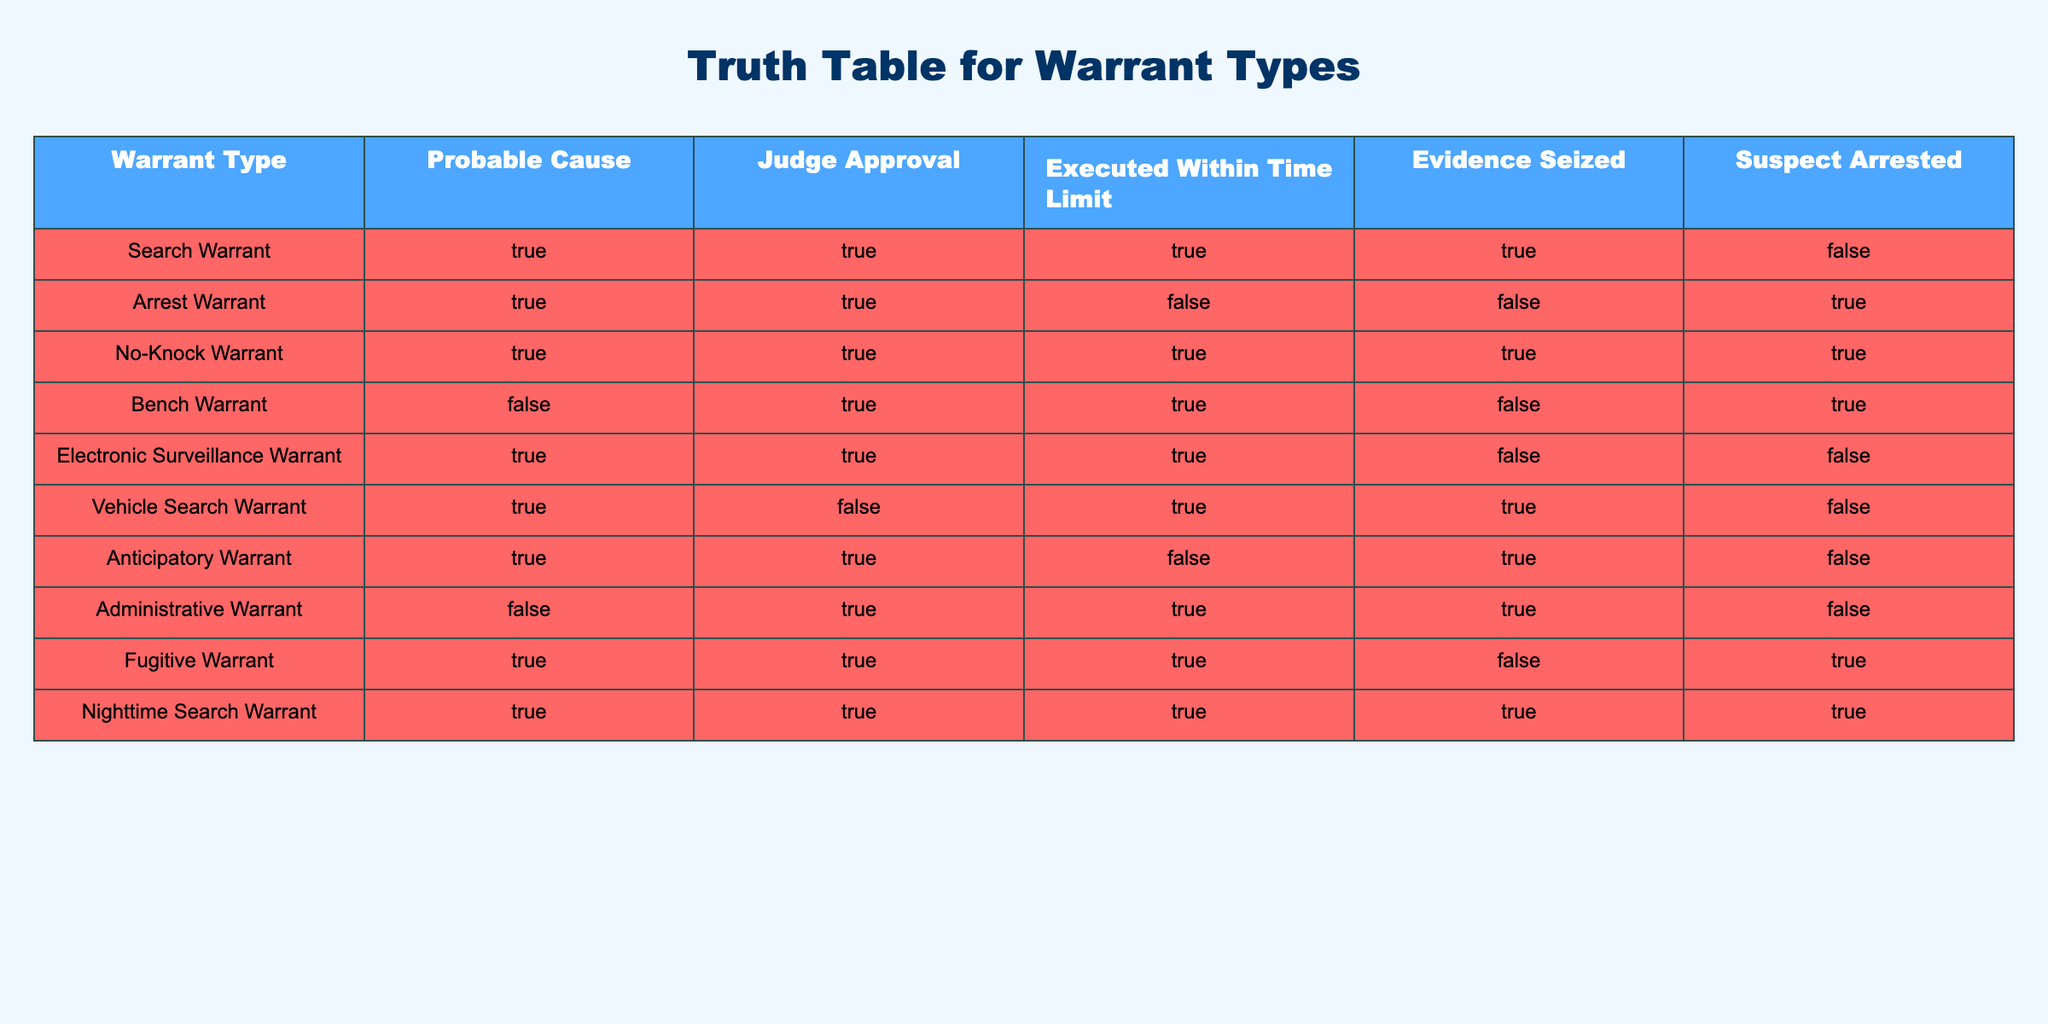What is the only warrant type where evidence was seized but the suspect was not arrested? The table shows that the Search Warrant type has evidence seized (TRUE) while the suspect was not arrested (FALSE). Other warrants either have both evidence seized and suspect arrested or neither.
Answer: Search Warrant How many warrant types have judge approval but no probable cause? The table has one warrant type - the Bench Warrant - that is marked with judge approval (TRUE) but has no probable cause (FALSE). Therefore, there is only one such warrant type.
Answer: 1 Which warrant types executed within the time limit also resulted in the suspect's arrest? From the table, the only warrant types that executed within the time limit (TRUE) and also resulted in a suspect's arrest (TRUE) are the Arrest Warrant and Nighttime Search Warrant. Thus, two types match this criterion.
Answer: 2 Is it true that no warrant types have a situation where evidence is seized but the suspect is not arrested? Looking through the table, it is evident that both the Search Warrant and Vehicle Search Warrant show evidence seized as TRUE, while the suspect arrest status is FALSE. This indicates that the statement is not true.
Answer: No What is the total number of types of warrants that allow for electronic surveillance? The table shows no specific warrant type labeled as permitting electronic surveillance, but it does include the Electronic Surveillance Warrant which has its own parameters. So, counting this, there is one type dedicated to electronic surveillance.
Answer: 1 Which warrant types executed within the time limit and have probable cause? The relevant warrant types fulfilling both conditions are the Search Warrant, No-Knock Warrant, Nighttime Search Warrant, and Fugitive Warrant. Each of these warrants shows executed within time limit (TRUE) and also meets probable cause (TRUE). Therefore, there are four types.
Answer: 4 What is the only warrant type that neither reported evidence seized nor led to a suspect being arrested? Among all the warrant types, the Arrest Warrant is noted for having no evidence seized (FALSE) and leading to a suspect's arrest (TRUE), making it the only one fitting this description according to the data table.
Answer: Arrest Warrant 